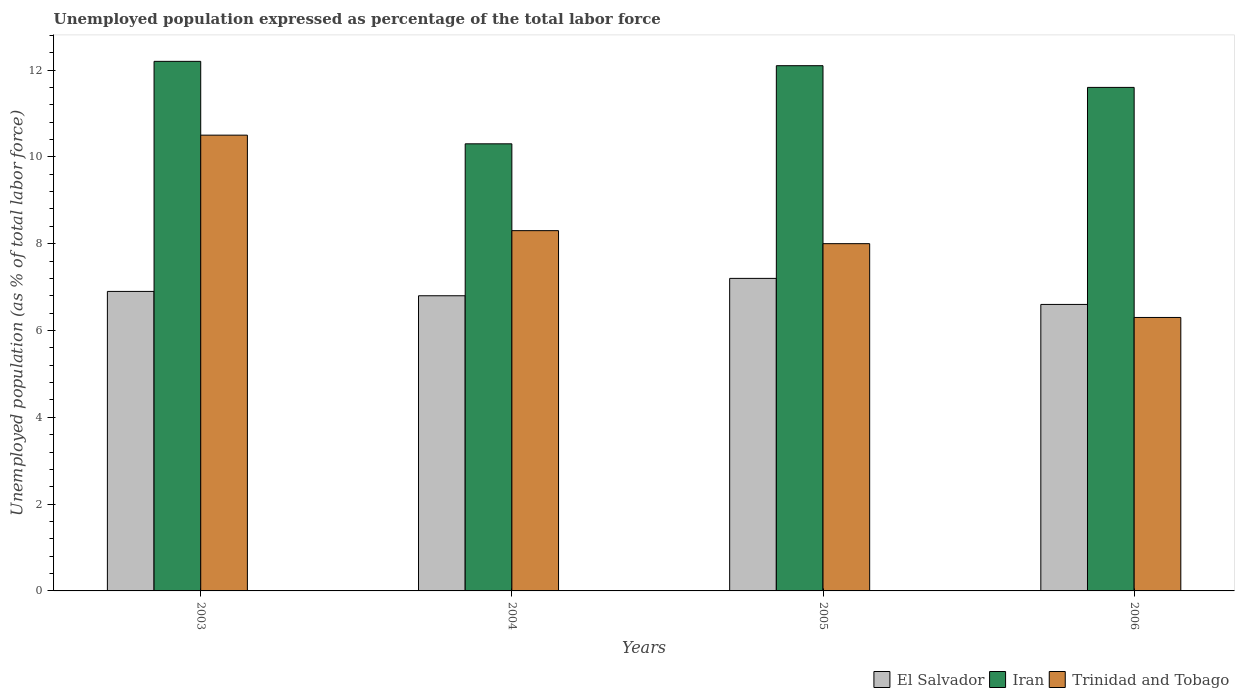Are the number of bars per tick equal to the number of legend labels?
Provide a succinct answer. Yes. How many bars are there on the 4th tick from the right?
Give a very brief answer. 3. What is the label of the 2nd group of bars from the left?
Keep it short and to the point. 2004. What is the unemployment in in Iran in 2005?
Offer a very short reply. 12.1. Across all years, what is the minimum unemployment in in Trinidad and Tobago?
Offer a very short reply. 6.3. In which year was the unemployment in in Trinidad and Tobago minimum?
Offer a very short reply. 2006. What is the total unemployment in in El Salvador in the graph?
Give a very brief answer. 27.5. What is the difference between the unemployment in in Iran in 2003 and that in 2004?
Your answer should be very brief. 1.9. What is the difference between the unemployment in in Iran in 2005 and the unemployment in in El Salvador in 2004?
Ensure brevity in your answer.  5.3. What is the average unemployment in in Trinidad and Tobago per year?
Ensure brevity in your answer.  8.28. In the year 2006, what is the difference between the unemployment in in Iran and unemployment in in El Salvador?
Provide a short and direct response. 5. What is the ratio of the unemployment in in Iran in 2004 to that in 2005?
Ensure brevity in your answer.  0.85. Is the unemployment in in El Salvador in 2003 less than that in 2004?
Provide a succinct answer. No. What is the difference between the highest and the second highest unemployment in in Iran?
Your answer should be very brief. 0.1. What is the difference between the highest and the lowest unemployment in in Trinidad and Tobago?
Your answer should be very brief. 4.2. In how many years, is the unemployment in in Iran greater than the average unemployment in in Iran taken over all years?
Give a very brief answer. 3. Is the sum of the unemployment in in El Salvador in 2004 and 2006 greater than the maximum unemployment in in Trinidad and Tobago across all years?
Provide a short and direct response. Yes. What does the 2nd bar from the left in 2004 represents?
Provide a succinct answer. Iran. What does the 2nd bar from the right in 2005 represents?
Offer a terse response. Iran. Is it the case that in every year, the sum of the unemployment in in El Salvador and unemployment in in Iran is greater than the unemployment in in Trinidad and Tobago?
Give a very brief answer. Yes. Are all the bars in the graph horizontal?
Offer a very short reply. No. How many years are there in the graph?
Offer a very short reply. 4. Are the values on the major ticks of Y-axis written in scientific E-notation?
Provide a succinct answer. No. Does the graph contain any zero values?
Offer a terse response. No. Where does the legend appear in the graph?
Your answer should be very brief. Bottom right. How many legend labels are there?
Offer a terse response. 3. How are the legend labels stacked?
Offer a terse response. Horizontal. What is the title of the graph?
Provide a short and direct response. Unemployed population expressed as percentage of the total labor force. Does "Lithuania" appear as one of the legend labels in the graph?
Your answer should be very brief. No. What is the label or title of the Y-axis?
Ensure brevity in your answer.  Unemployed population (as % of total labor force). What is the Unemployed population (as % of total labor force) in El Salvador in 2003?
Provide a succinct answer. 6.9. What is the Unemployed population (as % of total labor force) of Iran in 2003?
Your response must be concise. 12.2. What is the Unemployed population (as % of total labor force) of El Salvador in 2004?
Your response must be concise. 6.8. What is the Unemployed population (as % of total labor force) in Iran in 2004?
Keep it short and to the point. 10.3. What is the Unemployed population (as % of total labor force) of Trinidad and Tobago in 2004?
Keep it short and to the point. 8.3. What is the Unemployed population (as % of total labor force) in El Salvador in 2005?
Keep it short and to the point. 7.2. What is the Unemployed population (as % of total labor force) of Iran in 2005?
Your answer should be compact. 12.1. What is the Unemployed population (as % of total labor force) in Trinidad and Tobago in 2005?
Provide a succinct answer. 8. What is the Unemployed population (as % of total labor force) of El Salvador in 2006?
Provide a succinct answer. 6.6. What is the Unemployed population (as % of total labor force) in Iran in 2006?
Provide a short and direct response. 11.6. What is the Unemployed population (as % of total labor force) in Trinidad and Tobago in 2006?
Provide a succinct answer. 6.3. Across all years, what is the maximum Unemployed population (as % of total labor force) of El Salvador?
Keep it short and to the point. 7.2. Across all years, what is the maximum Unemployed population (as % of total labor force) of Iran?
Ensure brevity in your answer.  12.2. Across all years, what is the maximum Unemployed population (as % of total labor force) in Trinidad and Tobago?
Keep it short and to the point. 10.5. Across all years, what is the minimum Unemployed population (as % of total labor force) in El Salvador?
Provide a short and direct response. 6.6. Across all years, what is the minimum Unemployed population (as % of total labor force) in Iran?
Ensure brevity in your answer.  10.3. Across all years, what is the minimum Unemployed population (as % of total labor force) of Trinidad and Tobago?
Ensure brevity in your answer.  6.3. What is the total Unemployed population (as % of total labor force) of El Salvador in the graph?
Your response must be concise. 27.5. What is the total Unemployed population (as % of total labor force) of Iran in the graph?
Provide a succinct answer. 46.2. What is the total Unemployed population (as % of total labor force) of Trinidad and Tobago in the graph?
Keep it short and to the point. 33.1. What is the difference between the Unemployed population (as % of total labor force) in Iran in 2003 and that in 2004?
Your answer should be compact. 1.9. What is the difference between the Unemployed population (as % of total labor force) in El Salvador in 2003 and that in 2005?
Your answer should be very brief. -0.3. What is the difference between the Unemployed population (as % of total labor force) of Iran in 2003 and that in 2005?
Your answer should be compact. 0.1. What is the difference between the Unemployed population (as % of total labor force) in El Salvador in 2003 and that in 2006?
Provide a succinct answer. 0.3. What is the difference between the Unemployed population (as % of total labor force) in Trinidad and Tobago in 2003 and that in 2006?
Offer a terse response. 4.2. What is the difference between the Unemployed population (as % of total labor force) of El Salvador in 2004 and that in 2005?
Offer a terse response. -0.4. What is the difference between the Unemployed population (as % of total labor force) in Iran in 2004 and that in 2005?
Provide a short and direct response. -1.8. What is the difference between the Unemployed population (as % of total labor force) of Trinidad and Tobago in 2004 and that in 2005?
Give a very brief answer. 0.3. What is the difference between the Unemployed population (as % of total labor force) in El Salvador in 2003 and the Unemployed population (as % of total labor force) in Trinidad and Tobago in 2004?
Give a very brief answer. -1.4. What is the difference between the Unemployed population (as % of total labor force) in El Salvador in 2003 and the Unemployed population (as % of total labor force) in Iran in 2005?
Your answer should be very brief. -5.2. What is the difference between the Unemployed population (as % of total labor force) of El Salvador in 2003 and the Unemployed population (as % of total labor force) of Trinidad and Tobago in 2005?
Your answer should be very brief. -1.1. What is the difference between the Unemployed population (as % of total labor force) of Iran in 2003 and the Unemployed population (as % of total labor force) of Trinidad and Tobago in 2005?
Give a very brief answer. 4.2. What is the difference between the Unemployed population (as % of total labor force) in El Salvador in 2003 and the Unemployed population (as % of total labor force) in Trinidad and Tobago in 2006?
Keep it short and to the point. 0.6. What is the difference between the Unemployed population (as % of total labor force) in Iran in 2003 and the Unemployed population (as % of total labor force) in Trinidad and Tobago in 2006?
Offer a terse response. 5.9. What is the difference between the Unemployed population (as % of total labor force) in El Salvador in 2004 and the Unemployed population (as % of total labor force) in Trinidad and Tobago in 2005?
Provide a short and direct response. -1.2. What is the difference between the Unemployed population (as % of total labor force) in Iran in 2004 and the Unemployed population (as % of total labor force) in Trinidad and Tobago in 2006?
Provide a succinct answer. 4. What is the difference between the Unemployed population (as % of total labor force) of Iran in 2005 and the Unemployed population (as % of total labor force) of Trinidad and Tobago in 2006?
Your response must be concise. 5.8. What is the average Unemployed population (as % of total labor force) in El Salvador per year?
Offer a terse response. 6.88. What is the average Unemployed population (as % of total labor force) of Iran per year?
Offer a very short reply. 11.55. What is the average Unemployed population (as % of total labor force) in Trinidad and Tobago per year?
Offer a terse response. 8.28. In the year 2003, what is the difference between the Unemployed population (as % of total labor force) of El Salvador and Unemployed population (as % of total labor force) of Iran?
Provide a succinct answer. -5.3. In the year 2004, what is the difference between the Unemployed population (as % of total labor force) of El Salvador and Unemployed population (as % of total labor force) of Iran?
Offer a terse response. -3.5. In the year 2004, what is the difference between the Unemployed population (as % of total labor force) of El Salvador and Unemployed population (as % of total labor force) of Trinidad and Tobago?
Keep it short and to the point. -1.5. In the year 2005, what is the difference between the Unemployed population (as % of total labor force) in El Salvador and Unemployed population (as % of total labor force) in Iran?
Keep it short and to the point. -4.9. In the year 2006, what is the difference between the Unemployed population (as % of total labor force) in Iran and Unemployed population (as % of total labor force) in Trinidad and Tobago?
Your answer should be very brief. 5.3. What is the ratio of the Unemployed population (as % of total labor force) in El Salvador in 2003 to that in 2004?
Ensure brevity in your answer.  1.01. What is the ratio of the Unemployed population (as % of total labor force) in Iran in 2003 to that in 2004?
Make the answer very short. 1.18. What is the ratio of the Unemployed population (as % of total labor force) in Trinidad and Tobago in 2003 to that in 2004?
Provide a short and direct response. 1.27. What is the ratio of the Unemployed population (as % of total labor force) in El Salvador in 2003 to that in 2005?
Provide a succinct answer. 0.96. What is the ratio of the Unemployed population (as % of total labor force) in Iran in 2003 to that in 2005?
Give a very brief answer. 1.01. What is the ratio of the Unemployed population (as % of total labor force) of Trinidad and Tobago in 2003 to that in 2005?
Your response must be concise. 1.31. What is the ratio of the Unemployed population (as % of total labor force) of El Salvador in 2003 to that in 2006?
Make the answer very short. 1.05. What is the ratio of the Unemployed population (as % of total labor force) of Iran in 2003 to that in 2006?
Your answer should be very brief. 1.05. What is the ratio of the Unemployed population (as % of total labor force) in El Salvador in 2004 to that in 2005?
Provide a short and direct response. 0.94. What is the ratio of the Unemployed population (as % of total labor force) in Iran in 2004 to that in 2005?
Keep it short and to the point. 0.85. What is the ratio of the Unemployed population (as % of total labor force) in Trinidad and Tobago in 2004 to that in 2005?
Make the answer very short. 1.04. What is the ratio of the Unemployed population (as % of total labor force) in El Salvador in 2004 to that in 2006?
Make the answer very short. 1.03. What is the ratio of the Unemployed population (as % of total labor force) in Iran in 2004 to that in 2006?
Provide a succinct answer. 0.89. What is the ratio of the Unemployed population (as % of total labor force) in Trinidad and Tobago in 2004 to that in 2006?
Offer a very short reply. 1.32. What is the ratio of the Unemployed population (as % of total labor force) of El Salvador in 2005 to that in 2006?
Keep it short and to the point. 1.09. What is the ratio of the Unemployed population (as % of total labor force) of Iran in 2005 to that in 2006?
Your answer should be compact. 1.04. What is the ratio of the Unemployed population (as % of total labor force) of Trinidad and Tobago in 2005 to that in 2006?
Provide a short and direct response. 1.27. What is the difference between the highest and the second highest Unemployed population (as % of total labor force) in Iran?
Offer a very short reply. 0.1. What is the difference between the highest and the second highest Unemployed population (as % of total labor force) of Trinidad and Tobago?
Provide a short and direct response. 2.2. What is the difference between the highest and the lowest Unemployed population (as % of total labor force) of El Salvador?
Your answer should be very brief. 0.6. 